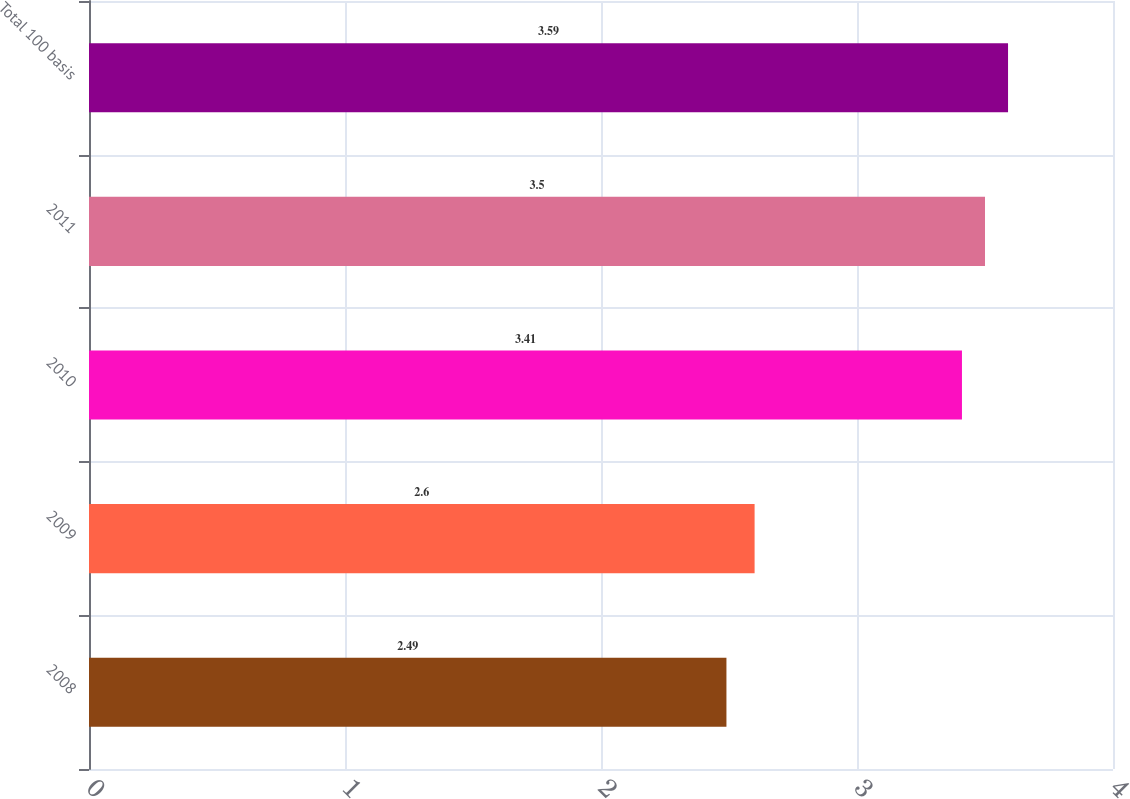Convert chart to OTSL. <chart><loc_0><loc_0><loc_500><loc_500><bar_chart><fcel>2008<fcel>2009<fcel>2010<fcel>2011<fcel>Total 100 basis<nl><fcel>2.49<fcel>2.6<fcel>3.41<fcel>3.5<fcel>3.59<nl></chart> 